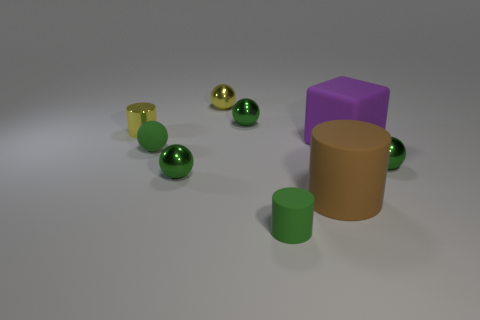What number of other things are there of the same material as the cube
Ensure brevity in your answer.  3. Do the small matte ball and the tiny metal ball on the right side of the brown rubber object have the same color?
Offer a very short reply. Yes. There is a matte object that is the same color as the tiny rubber cylinder; what shape is it?
Ensure brevity in your answer.  Sphere. What number of things are rubber things that are behind the big brown object or brown rubber cylinders?
Offer a very short reply. 3. What is the size of the yellow thing that is made of the same material as the tiny yellow cylinder?
Offer a terse response. Small. Is the number of big matte objects in front of the small green cylinder greater than the number of tiny green metallic balls?
Provide a short and direct response. No. There is a brown object; does it have the same shape as the green matte thing in front of the large rubber cylinder?
Offer a terse response. Yes. How many small objects are green matte things or rubber things?
Offer a very short reply. 2. What is the size of the ball that is the same color as the metal cylinder?
Provide a succinct answer. Small. There is a metallic sphere that is to the right of the small green rubber thing that is in front of the brown thing; what color is it?
Make the answer very short. Green. 